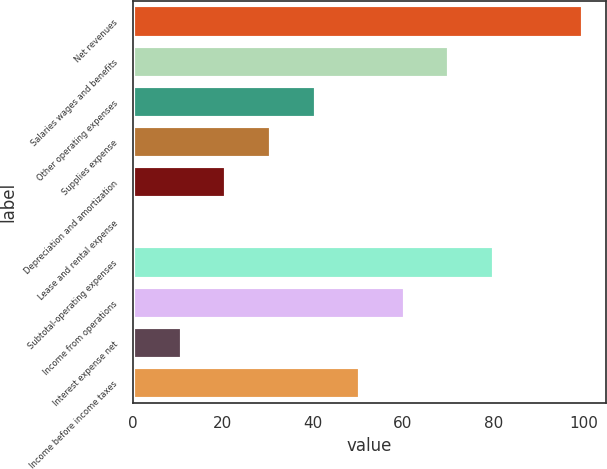Convert chart to OTSL. <chart><loc_0><loc_0><loc_500><loc_500><bar_chart><fcel>Net revenues<fcel>Salaries wages and benefits<fcel>Other operating expenses<fcel>Supplies expense<fcel>Depreciation and amortization<fcel>Lease and rental expense<fcel>Subtotal-operating expenses<fcel>Income from operations<fcel>Interest expense net<fcel>Income before income taxes<nl><fcel>100<fcel>70.3<fcel>40.6<fcel>30.7<fcel>20.8<fcel>1<fcel>80.2<fcel>60.4<fcel>10.9<fcel>50.5<nl></chart> 